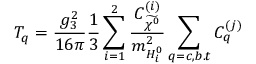Convert formula to latex. <formula><loc_0><loc_0><loc_500><loc_500>T _ { q } = \frac { g _ { 3 } ^ { 2 } } { 1 6 \pi } \frac { 1 } { 3 } \sum _ { i = 1 } ^ { 2 } \frac { C _ { \widetilde { \chi ^ { 0 } } } ^ { ( i ) } } { m _ { H _ { i } ^ { 0 } } ^ { 2 } } \sum _ { q = c , b . t } C _ { q } ^ { ( j ) }</formula> 